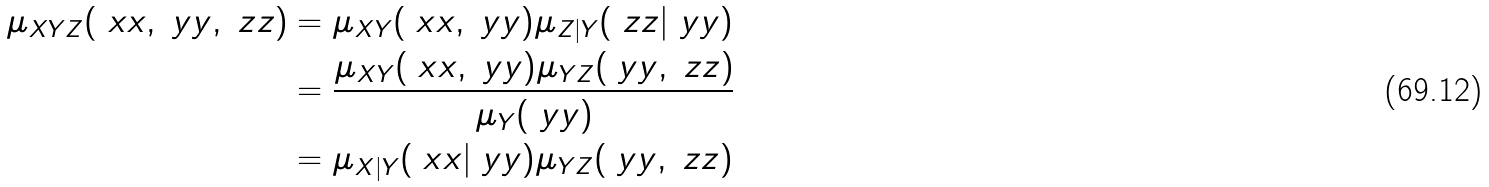<formula> <loc_0><loc_0><loc_500><loc_500>\mu _ { X Y Z } ( \ x x , \ y y , \ z z ) & = \mu _ { X Y } ( \ x x , \ y y ) \mu _ { Z | Y } ( \ z z | \ y y ) \\ & = \frac { \mu _ { X Y } ( \ x x , \ y y ) \mu _ { Y Z } ( \ y y , \ z z ) } { \mu _ { Y } ( \ y y ) } \\ & = \mu _ { X | Y } ( \ x x | \ y y ) \mu _ { Y Z } ( \ y y , \ z z )</formula> 